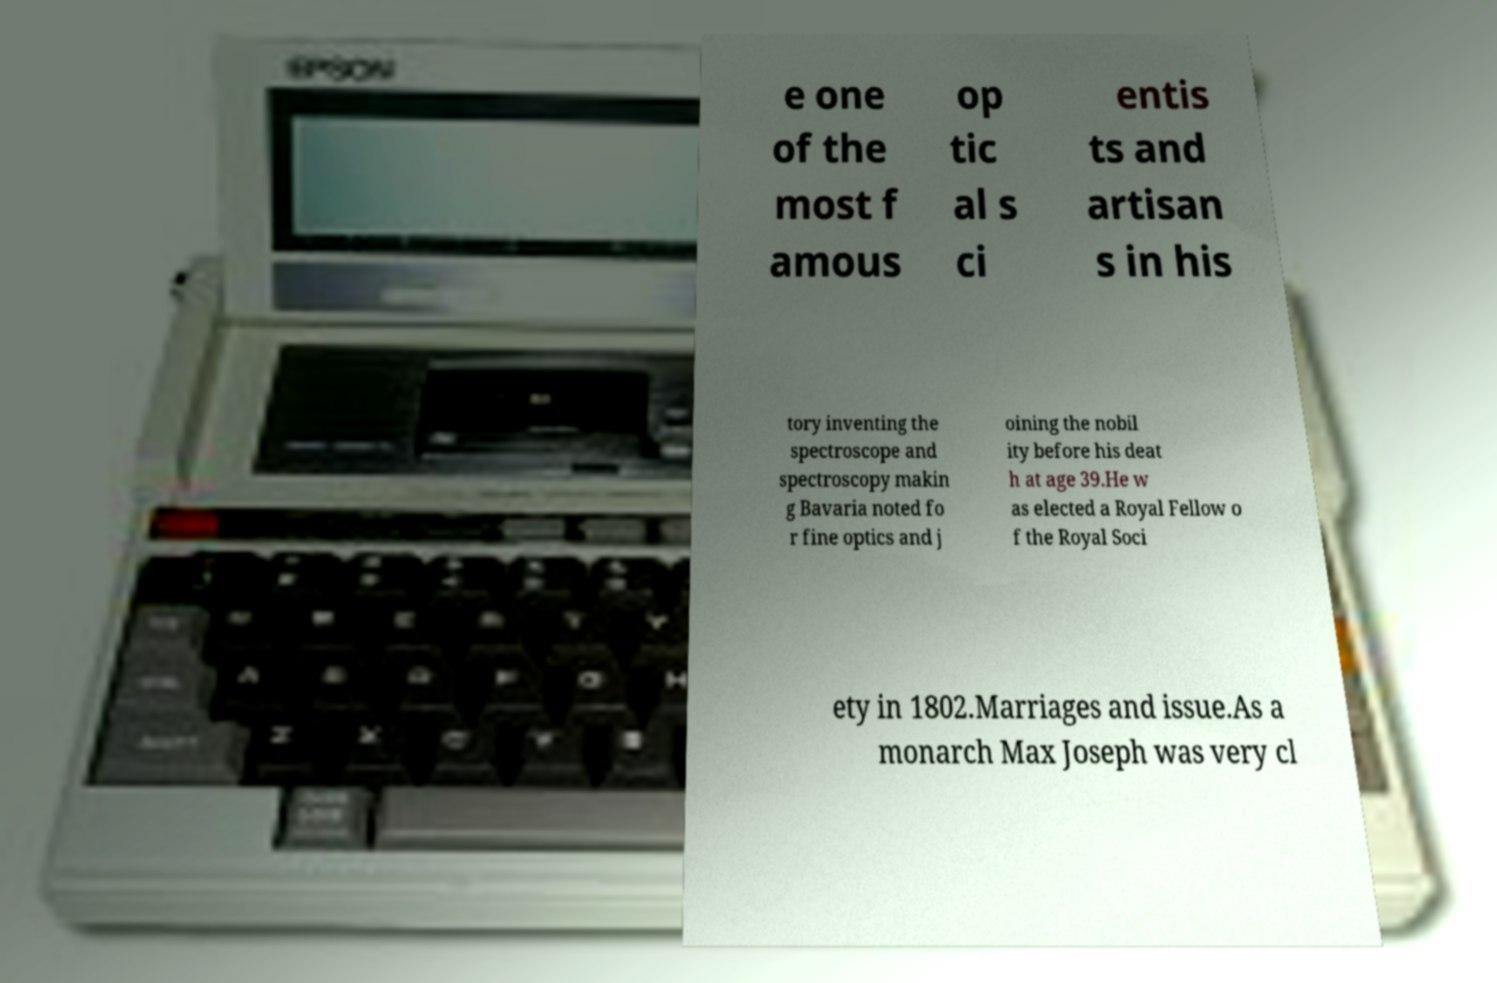For documentation purposes, I need the text within this image transcribed. Could you provide that? e one of the most f amous op tic al s ci entis ts and artisan s in his tory inventing the spectroscope and spectroscopy makin g Bavaria noted fo r fine optics and j oining the nobil ity before his deat h at age 39.He w as elected a Royal Fellow o f the Royal Soci ety in 1802.Marriages and issue.As a monarch Max Joseph was very cl 